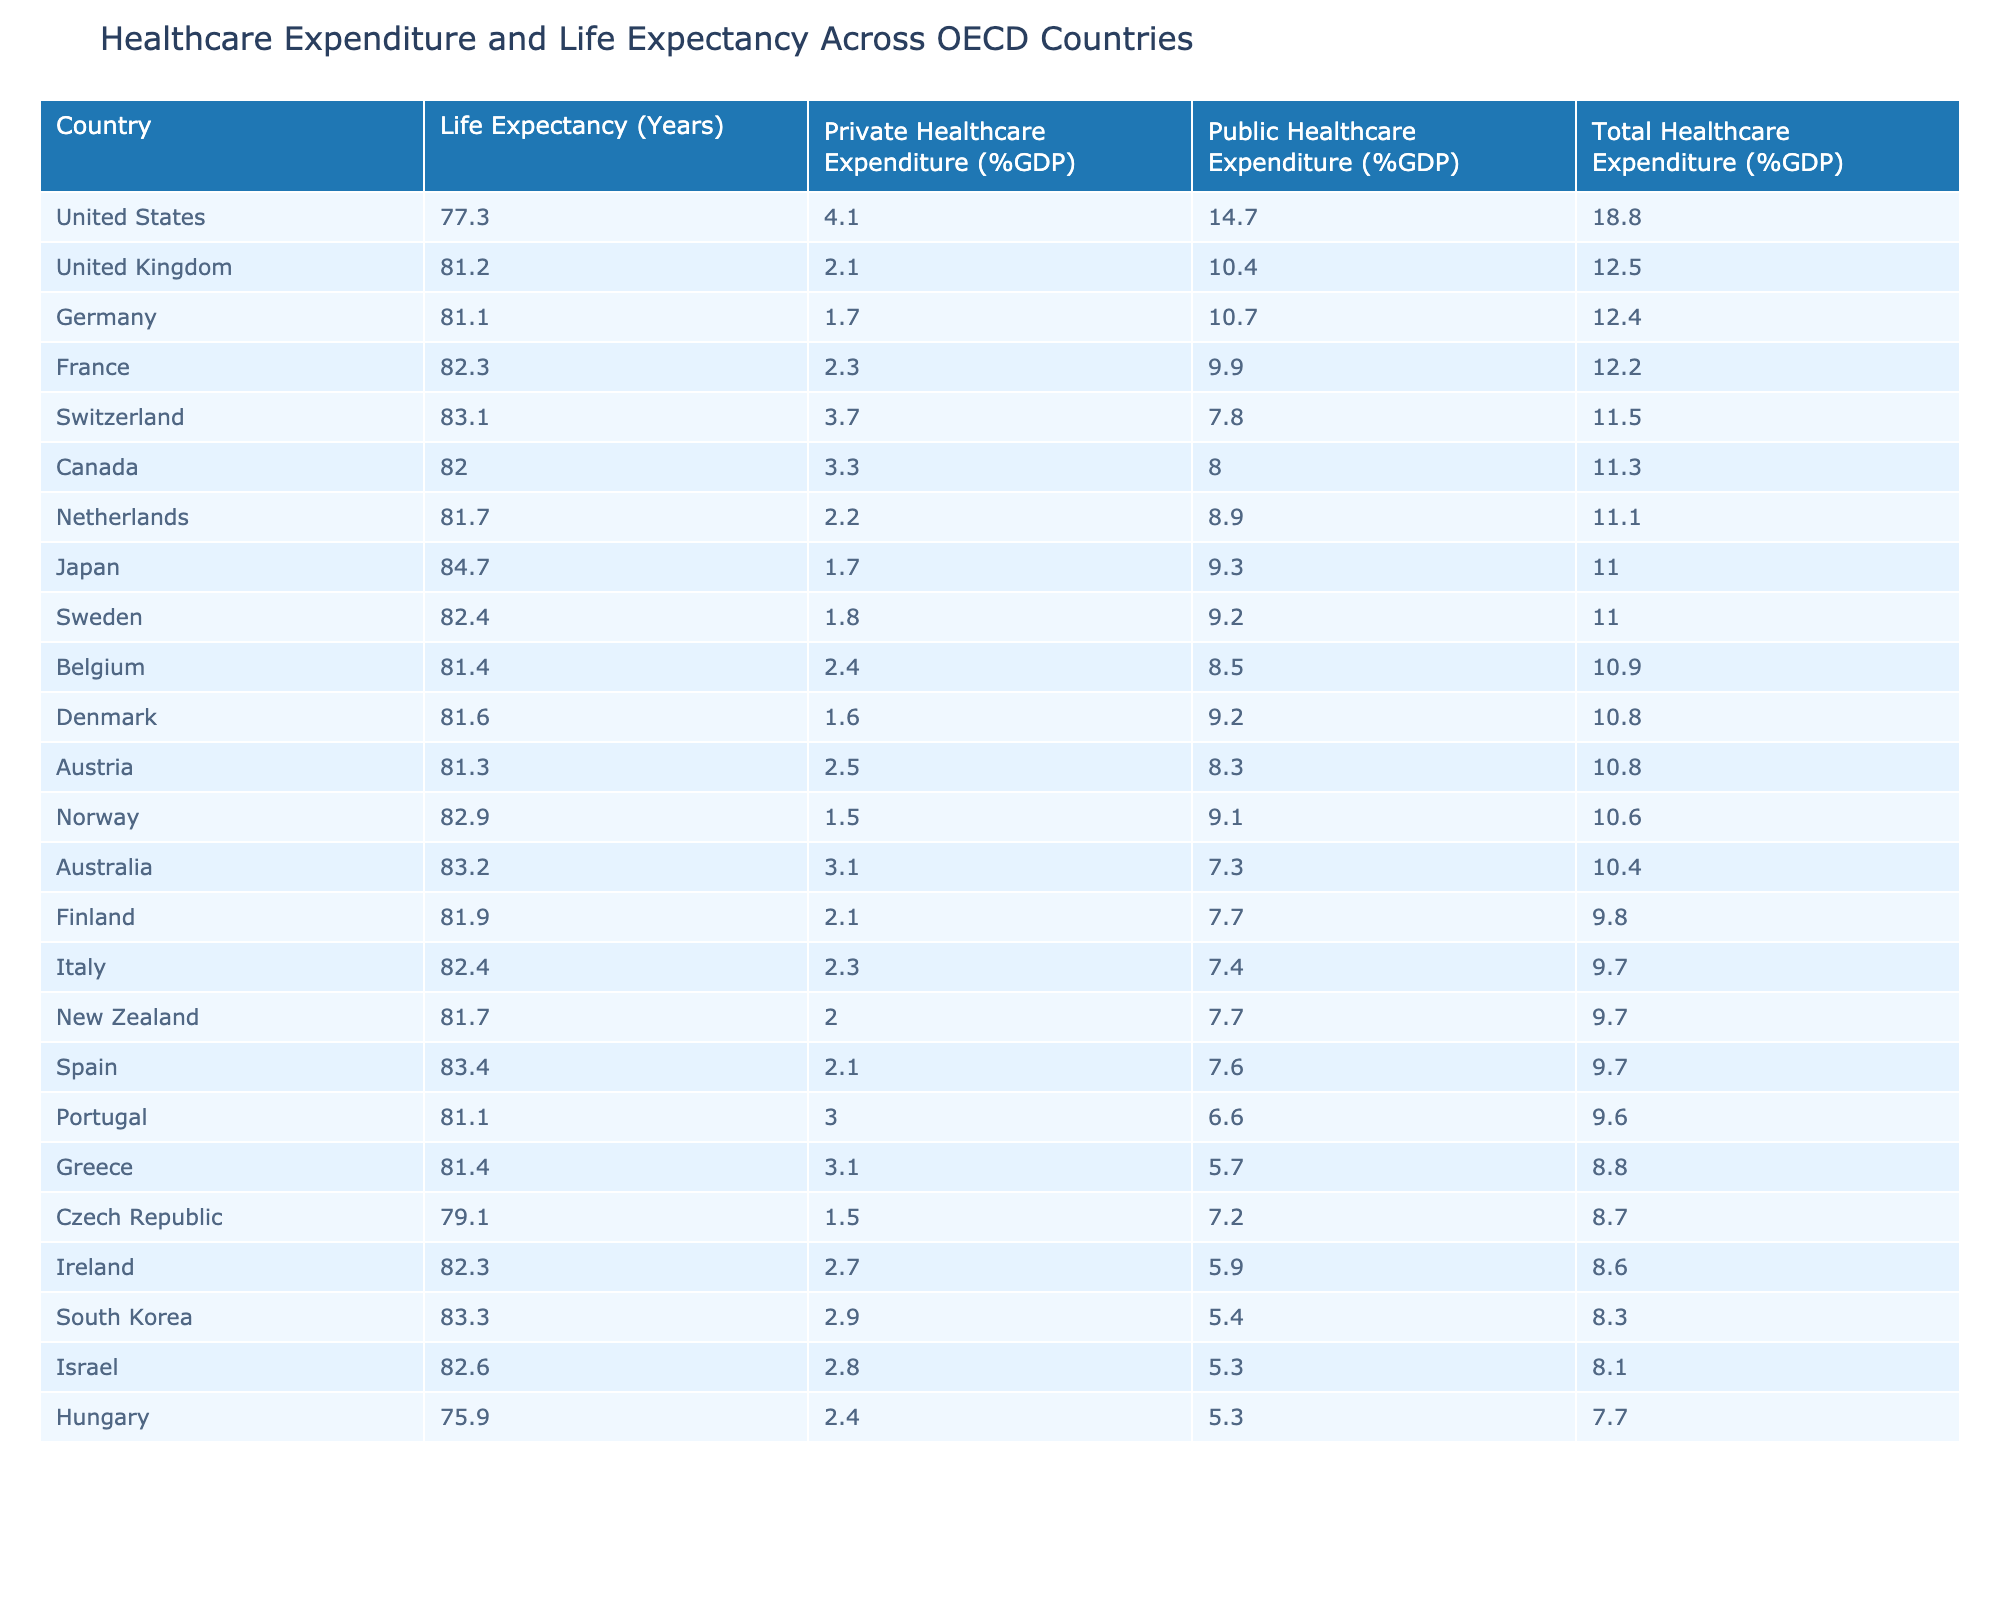What is the Public Healthcare Expenditure (%GDP) of the United States? The table lists the Public Healthcare Expenditure (%GDP) for the United States as 14.7, directly taken from the respective row for the country.
Answer: 14.7 Which country has the lowest Private Healthcare Expenditure (%GDP)? The table reveals that Hungary has the lowest Private Healthcare Expenditure at 2.4, when scanned among all listed countries.
Answer: Hungary What is the total Healthcare Expenditure (%GDP) for the United Kingdom? According to the table, the total Healthcare Expenditure (%GDP) for the United Kingdom is 12.5, as identified in its row.
Answer: 12.5 What is the average Life Expectancy (Years) for countries with a Public Healthcare System? First, identify the countries with a Public Healthcare System: United Kingdom, France, Canada, Sweden, Spain, Italy, Norway, Denmark, Finland, Portugal, Czech Republic, Hungary. Then, calculate their total life expectancy: (81.2 + 82.3 + 82.0 + 82.4 + 83.4 + 82.4 + 82.9 + 81.6 + 81.9 + 81.1 + 79.1 + 75.9) = 977.2. Then divide by the number of countries (12) to get the average: 977.2 / 12 = 81.43.
Answer: 81.43 Is it true that Israel has a higher Total Healthcare Expenditure (%GDP) than Canada? Comparing the Total Healthcare Expenditure (%GDP) values, Israel has 8.1 while Canada has 11.3. Since 8.1 is less than 11.3, the statement is false.
Answer: No Which country’s Private Healthcare Expenditure (%GDP) is closest to the average value of 2.3? To find the closest value, we first determine the average Private Healthcare Expenditure (%GDP) from the table: (4.1 + 2.1 + 1.7 + 2.3 + 3.3 + 1.7 + 3.1 + 1.8 + 2.2 + 3.7 + 2.1 + 2.5 + 2.0 + 2.7 + 3.0 + 3.1 + 2.8 + 2.9 + 1.5 + 2.4) / 20 = 2.57. Then, looking at the Private Healthcare Expenditure column, Switzerland (3.7) is the closest value to 2.3.
Answer: Switzerland Which country has a higher ratio of Private to Public Healthcare Expenditure (%GDP): Japan or Germany? By comparing the ratios, for Japan: 1.7(Private) / 9.3(Public) = 0.183, while for Germany: 1.7(Private)/ 10.7(Public) = 0.159. Since 0.183 is greater than 0.159, Japan has a higher ratio.
Answer: Japan What is the sum of Total Healthcare Expenditure (%GDP) for mixed healthcare system countries? Identify the mixed countries: United States, Germany, Japan, Australia, Netherlands, Switzerland, Belgium, Austria, New Zealand, Ireland, Greece, Israel, South Korea. Then sum their Total Healthcare Expenditure: (18.8 + 12.4 + 11.0 + 10.4 + 11.1 + 11.5 + 10.9 + 10.8 + 9.7 + 8.6 + 8.8 + 8.1 + 8.3) =  141.0.
Answer: 141.0 